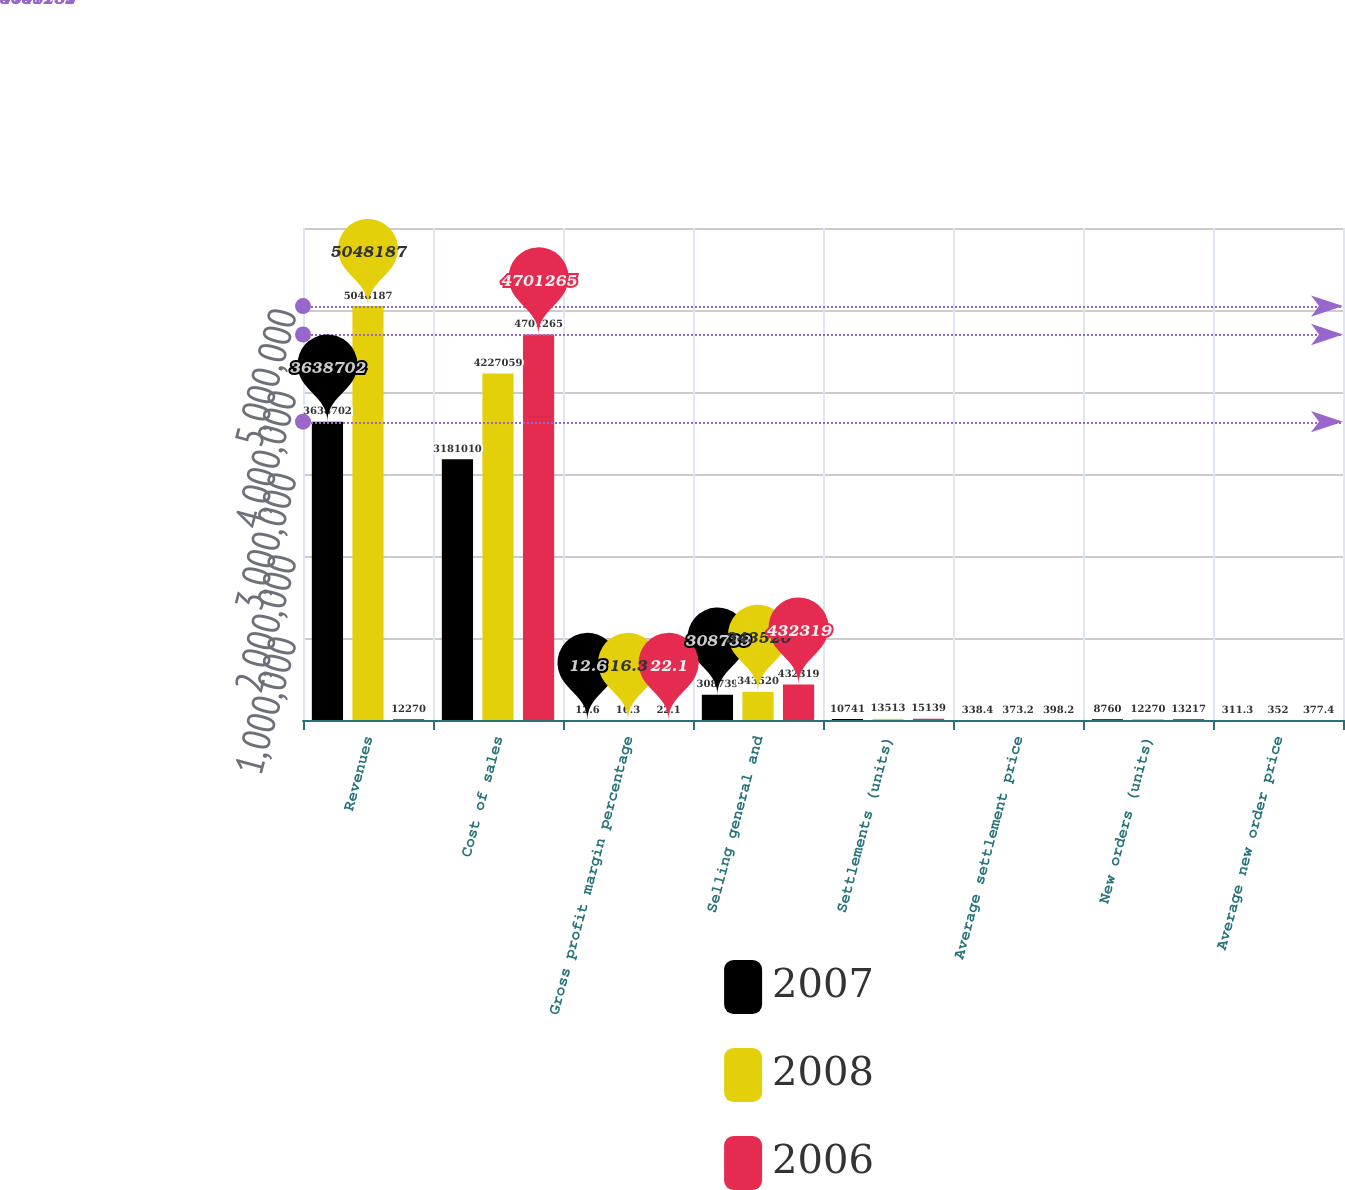Convert chart. <chart><loc_0><loc_0><loc_500><loc_500><stacked_bar_chart><ecel><fcel>Revenues<fcel>Cost of sales<fcel>Gross profit margin percentage<fcel>Selling general and<fcel>Settlements (units)<fcel>Average settlement price<fcel>New orders (units)<fcel>Average new order price<nl><fcel>2007<fcel>3.6387e+06<fcel>3.18101e+06<fcel>12.6<fcel>308739<fcel>10741<fcel>338.4<fcel>8760<fcel>311.3<nl><fcel>2008<fcel>5.04819e+06<fcel>4.22706e+06<fcel>16.3<fcel>343520<fcel>13513<fcel>373.2<fcel>12270<fcel>352<nl><fcel>2006<fcel>12270<fcel>4.70126e+06<fcel>22.1<fcel>432319<fcel>15139<fcel>398.2<fcel>13217<fcel>377.4<nl></chart> 